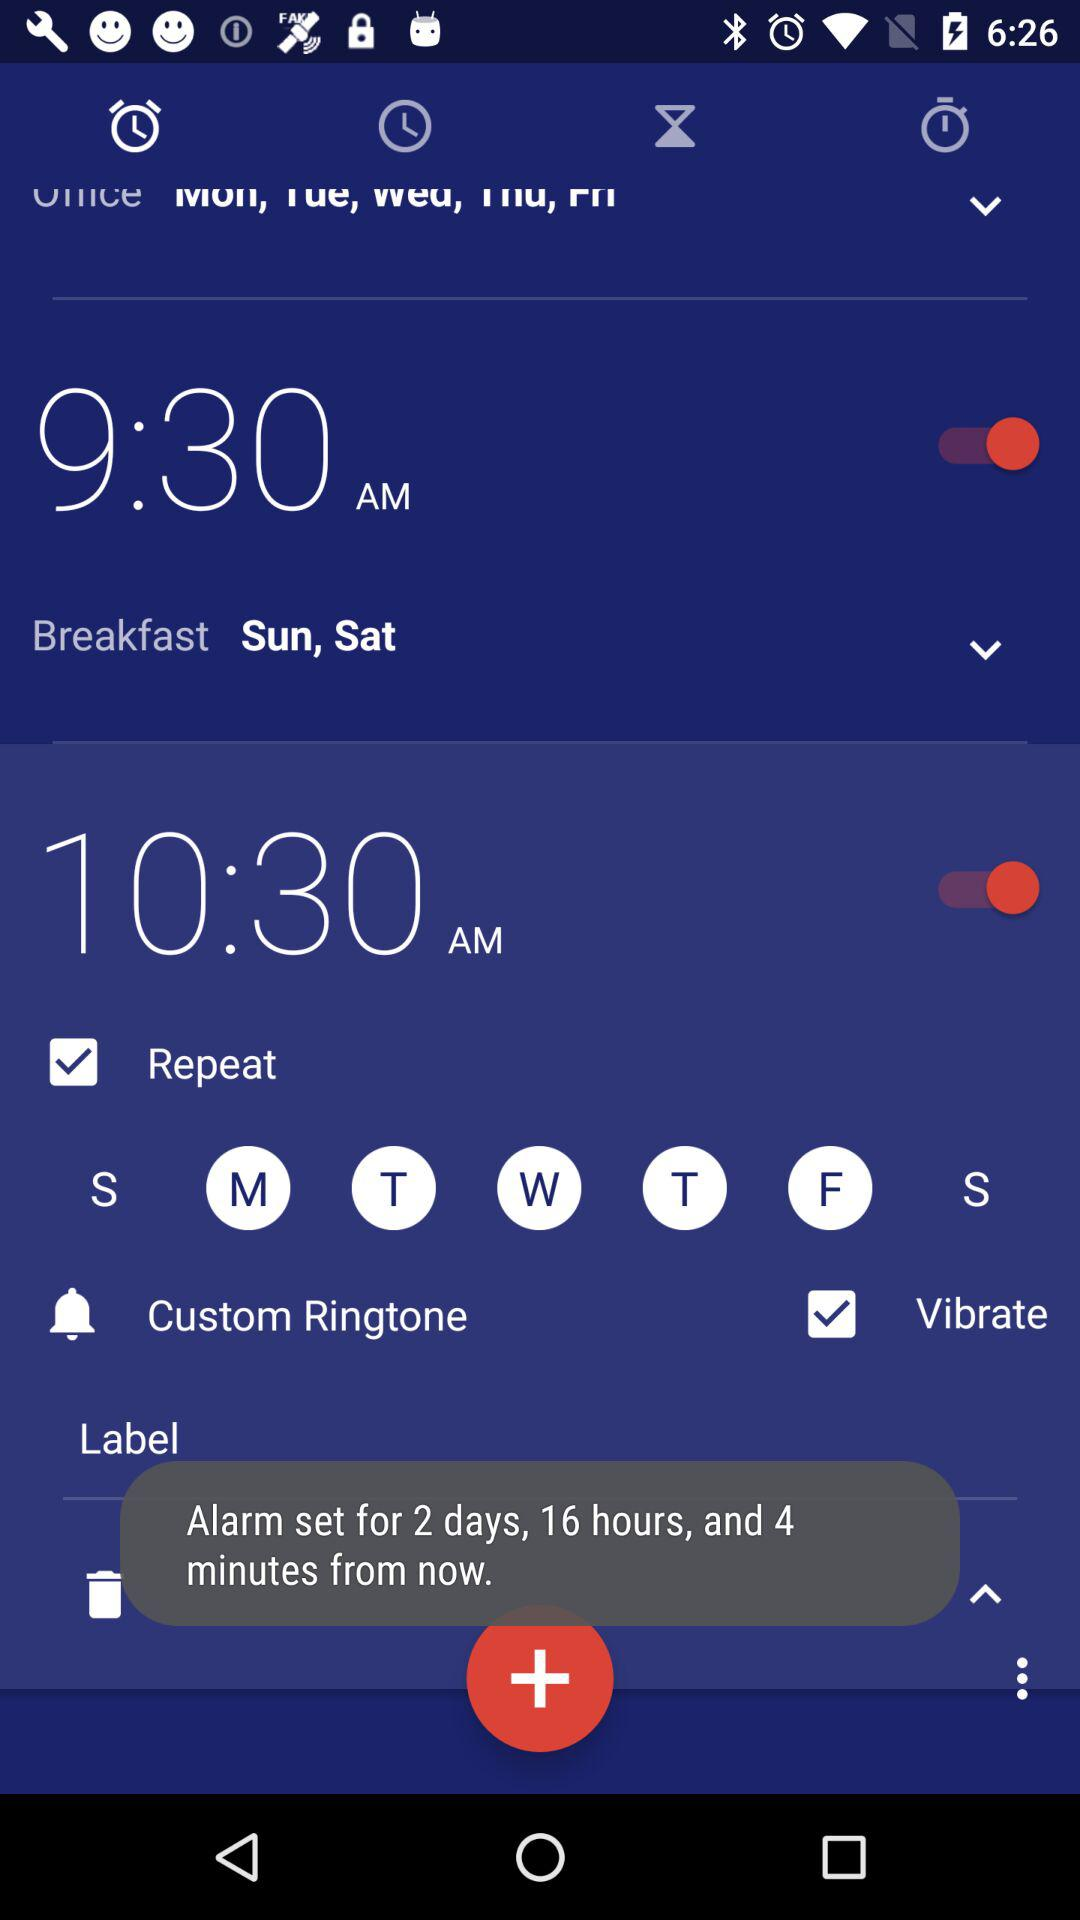What is the current status of the 10:30 am? The status is on. 